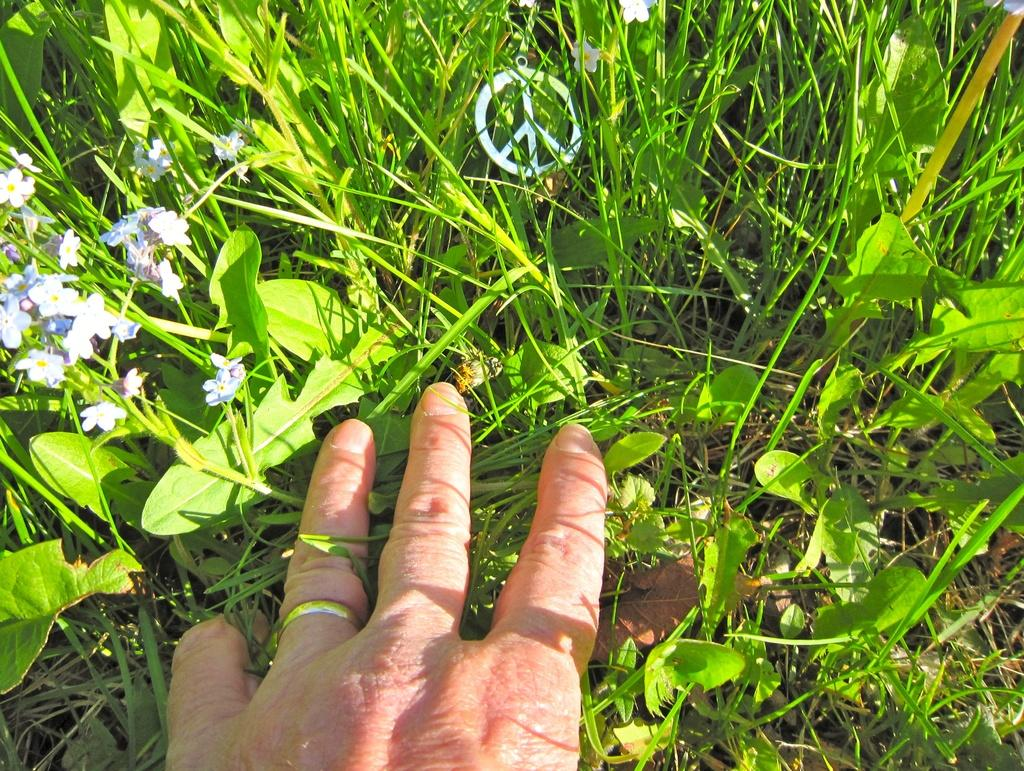What can be seen in the foreground of the image? There is a hand of a person in the foreground of the image. What is visible in the background of the image? There are flowers on plants and grass in the background of the image. Can you describe the logo in the background of the image? Yes, there is a logo in the background of the image. What type of fowl can be seen breathing heavily in the image? There is no fowl present in the image, and therefore no such activity can be observed. 